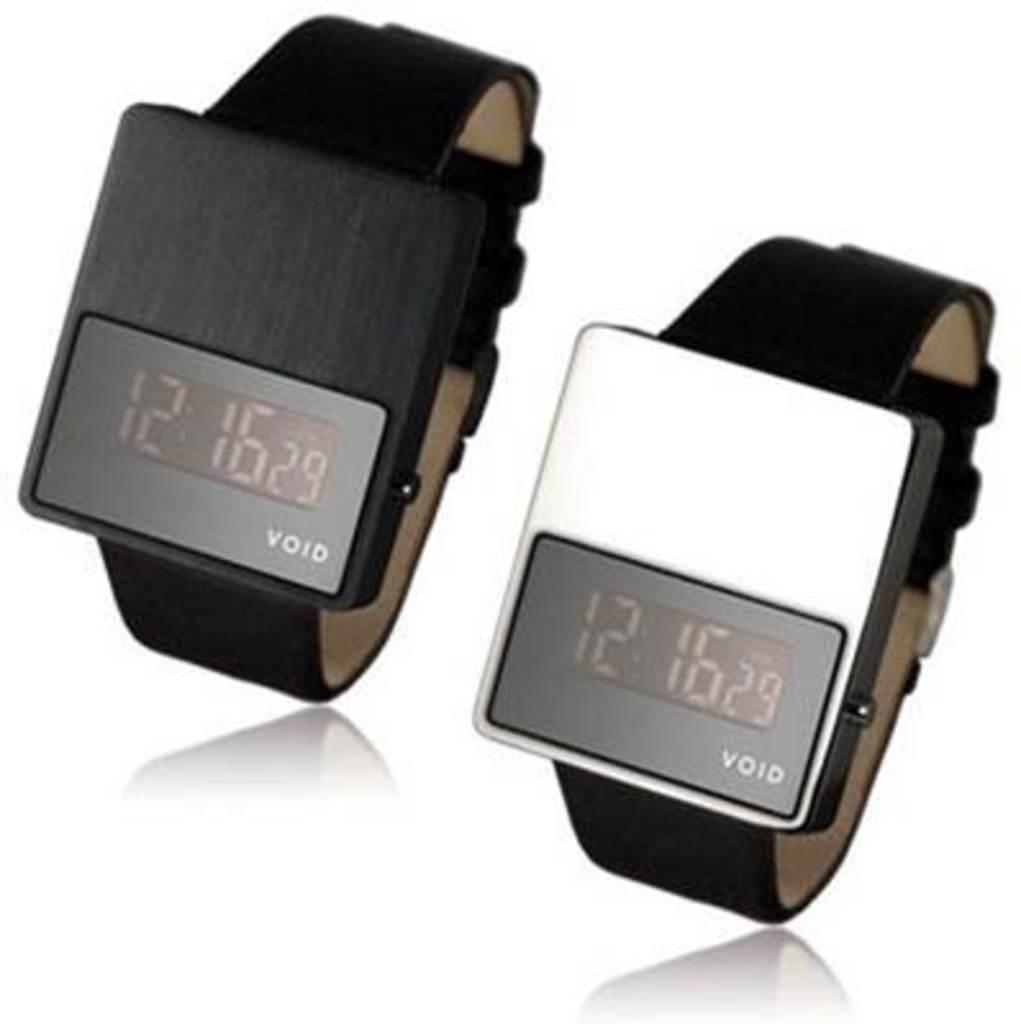<image>
Create a compact narrative representing the image presented. Two VOID watches show that the time is 12:16. 